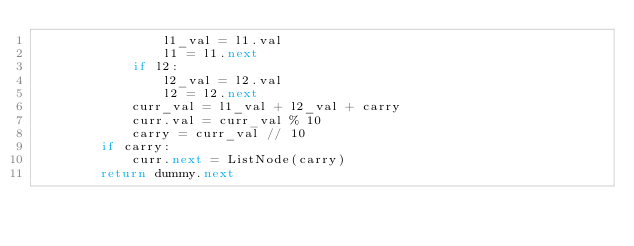<code> <loc_0><loc_0><loc_500><loc_500><_Python_>                l1_val = l1.val
                l1 = l1.next
            if l2:
                l2_val = l2.val
                l2 = l2.next
            curr_val = l1_val + l2_val + carry
            curr.val = curr_val % 10
            carry = curr_val // 10
        if carry:
            curr.next = ListNode(carry)
        return dummy.next
</code> 